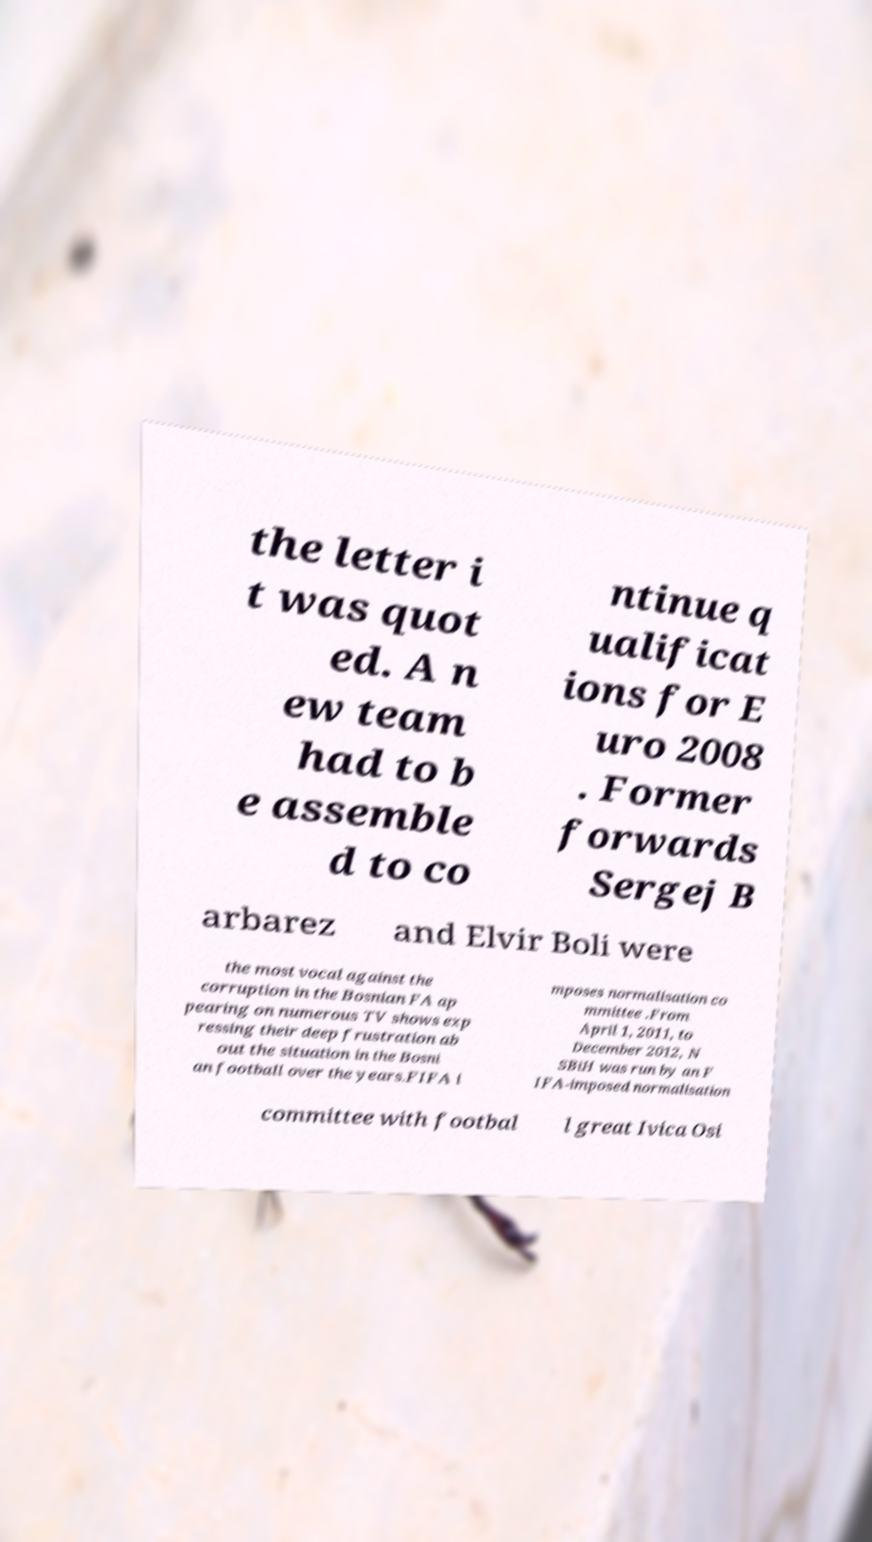Could you extract and type out the text from this image? the letter i t was quot ed. A n ew team had to b e assemble d to co ntinue q ualificat ions for E uro 2008 . Former forwards Sergej B arbarez and Elvir Boli were the most vocal against the corruption in the Bosnian FA ap pearing on numerous TV shows exp ressing their deep frustration ab out the situation in the Bosni an football over the years.FIFA i mposes normalisation co mmittee .From April 1, 2011, to December 2012, N SBiH was run by an F IFA-imposed normalisation committee with footbal l great Ivica Osi 